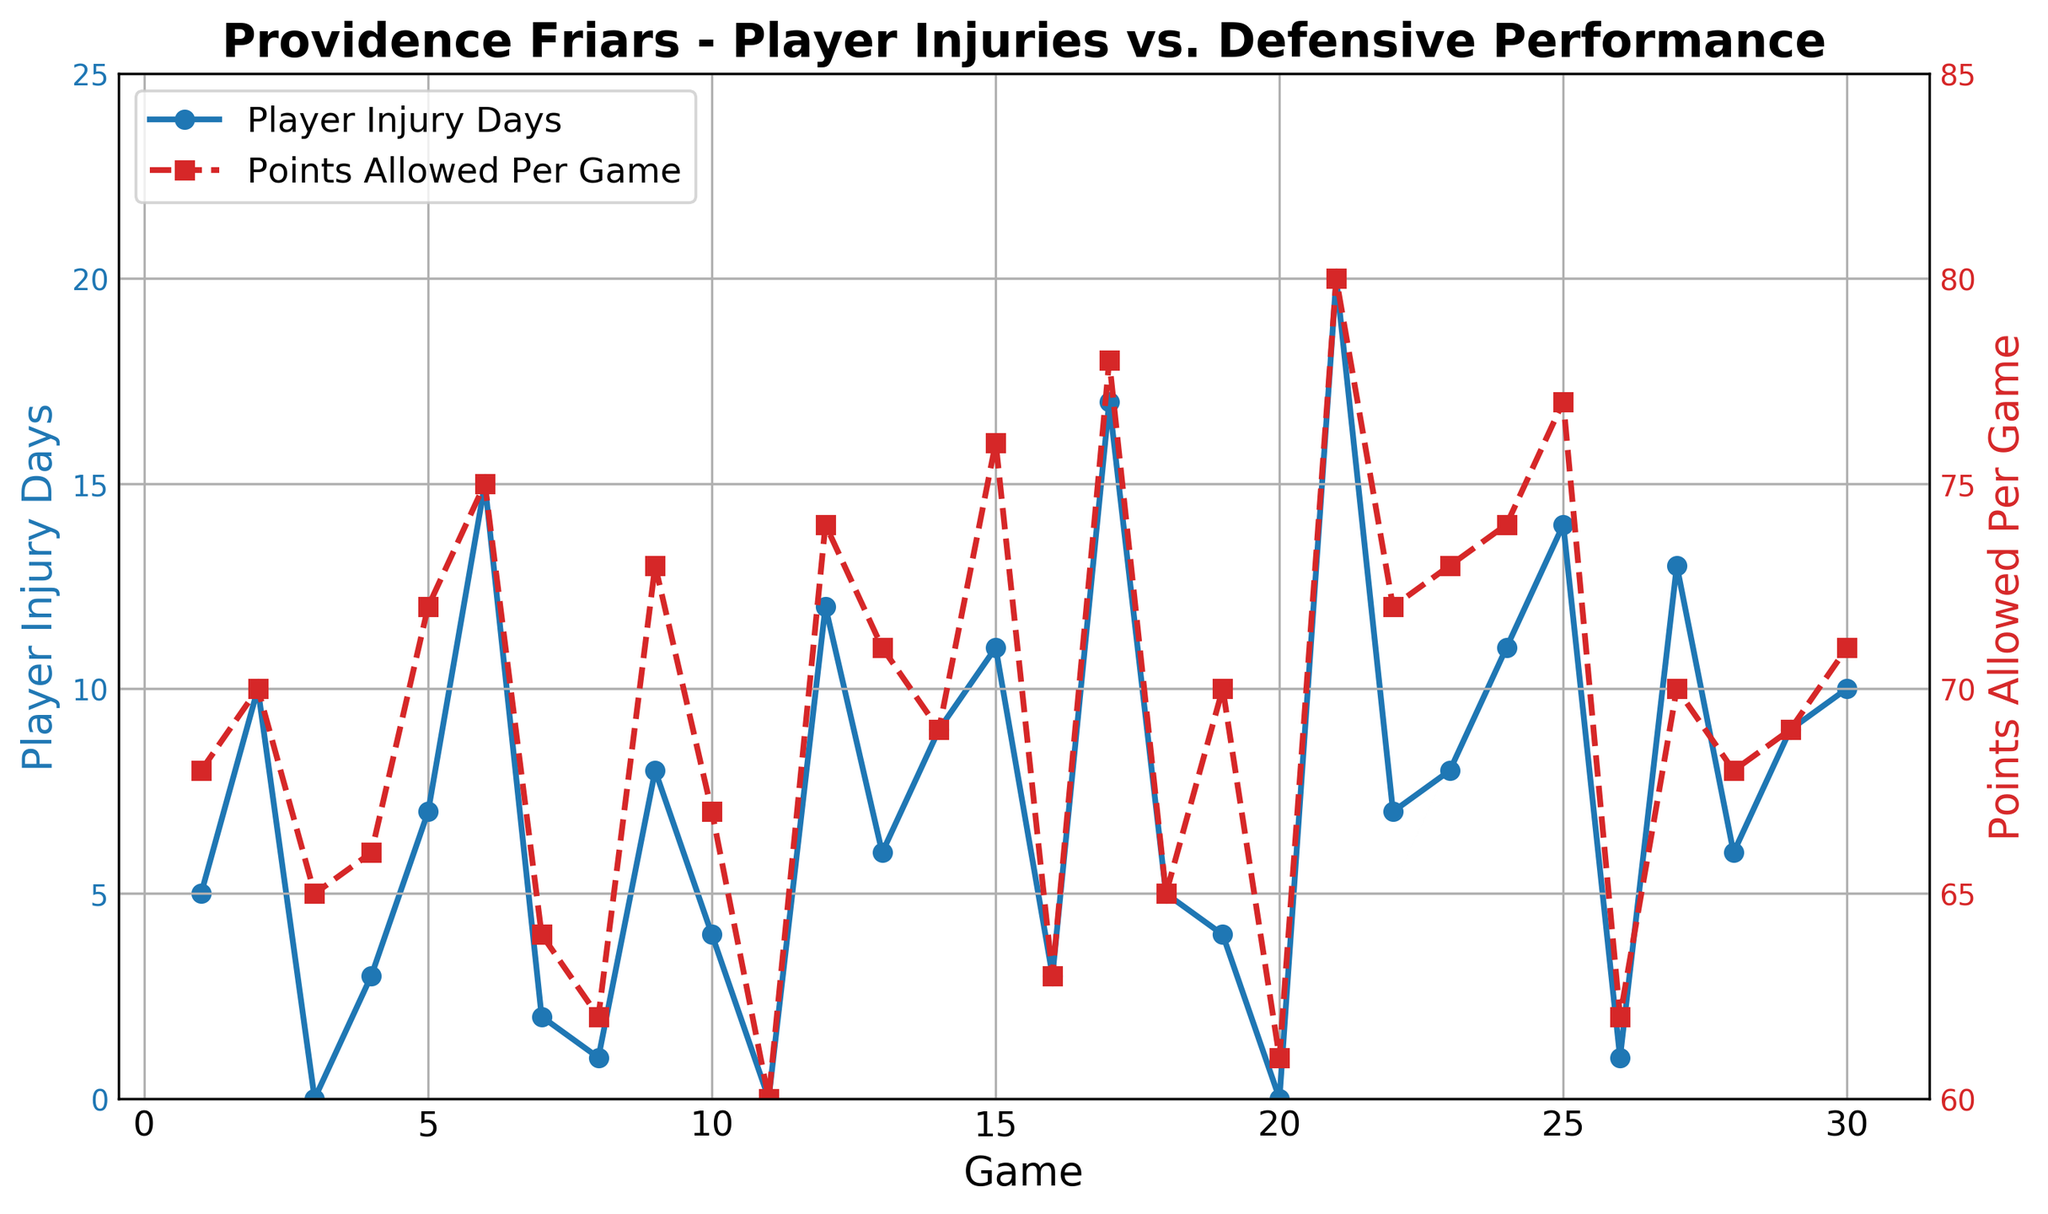What's the highest number of player injury days recorded and during which game did it occur? The blue line representing player injury days peaks at 20 during the 21st game.
Answer: 20 injury days in game 21 Do the games with 0 injury days correspond to lower points allowed per game? Identify the games with 0 injury days (games 3, 11, and 20). In these games, points allowed per game are 65, 60, and 61, respectively, which are relatively low.
Answer: Yes What's the average number of player injury days and points allowed per game in the first 10 games? Sum injury days (5+10+0+3+7+15+2+1+8+4) = 55, average = 55/10 = 5.5. Sum points allowed (68+70+65+66+72+75+64+62+73+67) = 682, average = 682/10 = 68.2
Answer: 5.5 injury days and 68.2 points Is there a correlation between higher injury days and higher points allowed per game? Observe the figure and note that peaks in injury days often correspond with higher points allowed (e.g., games 21 and 17). Therefore, they tend to move together.
Answer: Yes Between games 10 and 20, which game has the lowest points allowed per game and how many injury days were recorded in that game? Reviewing the red dashed line, game 20 has the lowest points allowed per game (61), and it recorded 0 injury days.
Answer: Game 20 with 0 injury days How often did the team allow more than 75 points per game, and what were the corresponding injury days for those games? The team allowed more than 75 points in games 15 (76 points with 11 injury days), 17 (78 points with 17 injury days), 21 (80 points with 20 injury days), 24 (74 points with 11 injury days), and 25 (77 points with 14 injury days).
Answer: 5 times, with 11, 17, 20, 11, 14 injury days What's the median number of points allowed per game over the season? Arrange points allowed in ascending order and find the middle value: The sorted points are [60, 61, 62, 62, 63, 64, 65, 65, 66, 67, 68, 68, 69, 69, 70, 70, 71, 71, 72, 72, 73, 73, 74, 74, 75, 76, 77, 78, 80], the median is the 15th value, which is 70.
Answer: 70 What’s the total number of injury days recorded for the whole season? Sum all values in the Player Injury Days column (5+10+0+3+7+15+2+1+8+4+0+12+6+9+11+3+17+5+4+0+20+7+8+11+14+1+13+6+9+10) = 221
Answer: 221 When the points allowed per game spike the most significantly, how many injury days were there? The most significant spike in points allowed is in game 21 (80 points), which coincides with 20 injury days.
Answer: 20 injury days 